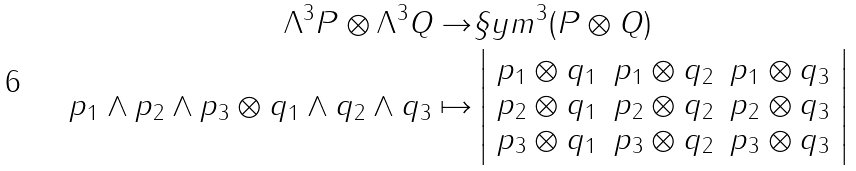<formula> <loc_0><loc_0><loc_500><loc_500>\Lambda ^ { 3 } P \otimes \Lambda ^ { 3 } Q \rightarrow & \S y m ^ { 3 } ( P \otimes Q ) \\ p _ { 1 } \wedge p _ { 2 } \wedge p _ { 3 } \otimes q _ { 1 } \wedge q _ { 2 } \wedge q _ { 3 } \mapsto & \left | \begin{array} { c c c } p _ { 1 } \otimes q _ { 1 } & p _ { 1 } \otimes q _ { 2 } & p _ { 1 } \otimes q _ { 3 } \\ p _ { 2 } \otimes q _ { 1 } & p _ { 2 } \otimes q _ { 2 } & p _ { 2 } \otimes q _ { 3 } \\ p _ { 3 } \otimes q _ { 1 } & p _ { 3 } \otimes q _ { 2 } & p _ { 3 } \otimes q _ { 3 } \end{array} \right |</formula> 